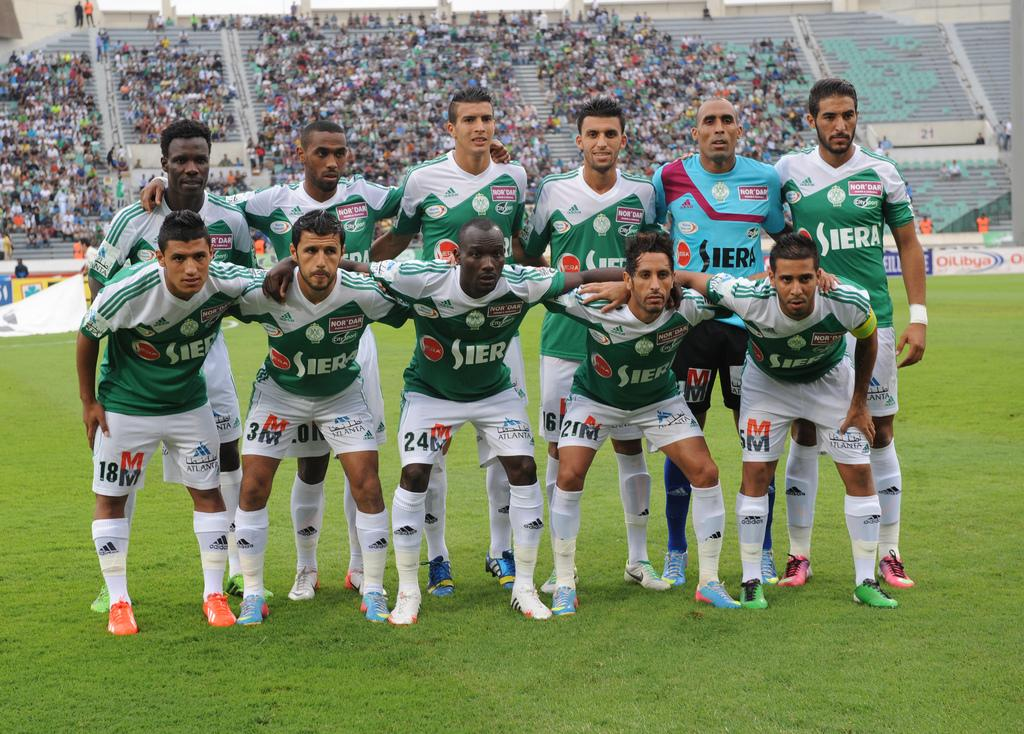<image>
Summarize the visual content of the image. sports team standing together for a portrait wear Seira jerseys 